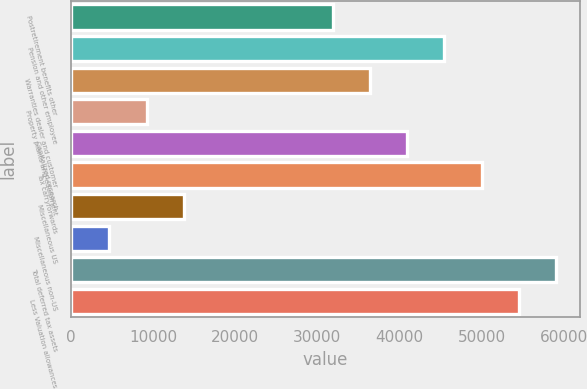<chart> <loc_0><loc_0><loc_500><loc_500><bar_chart><fcel>Postretirement benefits other<fcel>Pension and other employee<fcel>Warranties dealer and customer<fcel>Property plants and equipment<fcel>Capitalized research<fcel>Tax carryforwards<fcel>Miscellaneous US<fcel>Miscellaneous non-US<fcel>Total deferred tax assets<fcel>Less Valuation allowances<nl><fcel>31855.6<fcel>45448<fcel>36386.4<fcel>9201.6<fcel>40917.2<fcel>49978.8<fcel>13732.4<fcel>4670.8<fcel>59040.4<fcel>54509.6<nl></chart> 